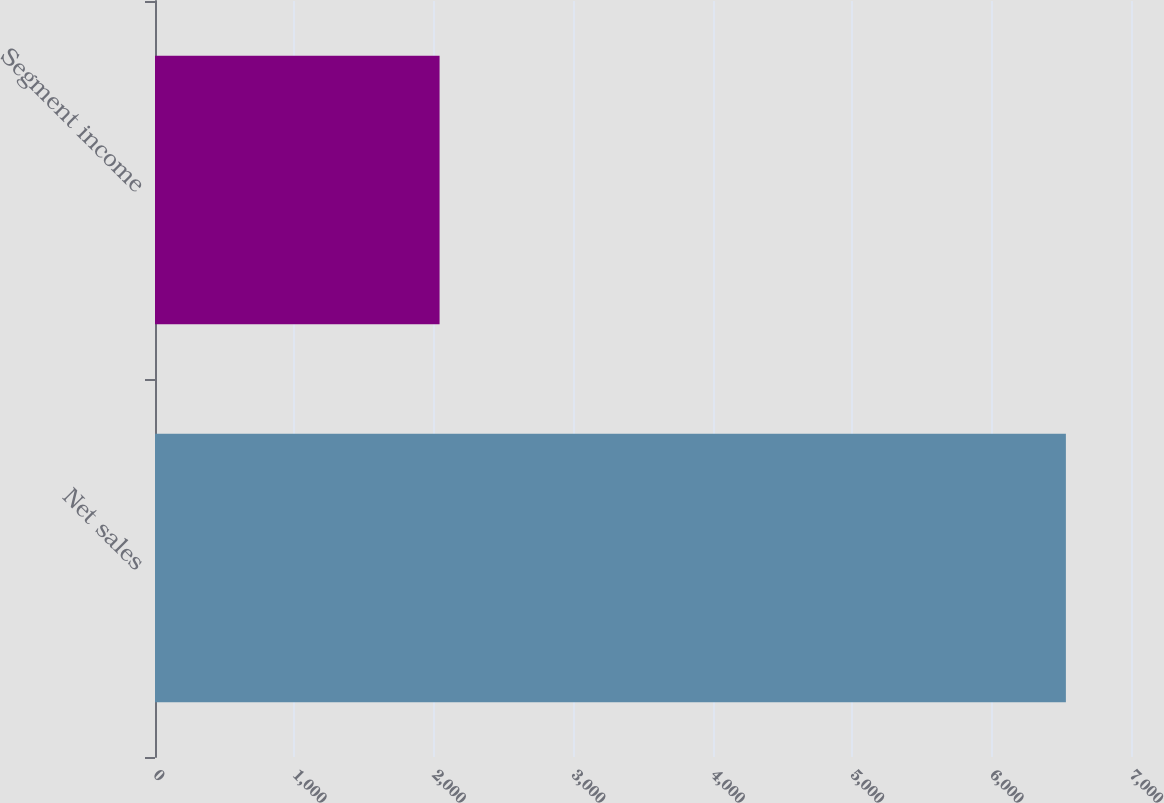<chart> <loc_0><loc_0><loc_500><loc_500><bar_chart><fcel>Net sales<fcel>Segment income<nl><fcel>6533<fcel>2041<nl></chart> 